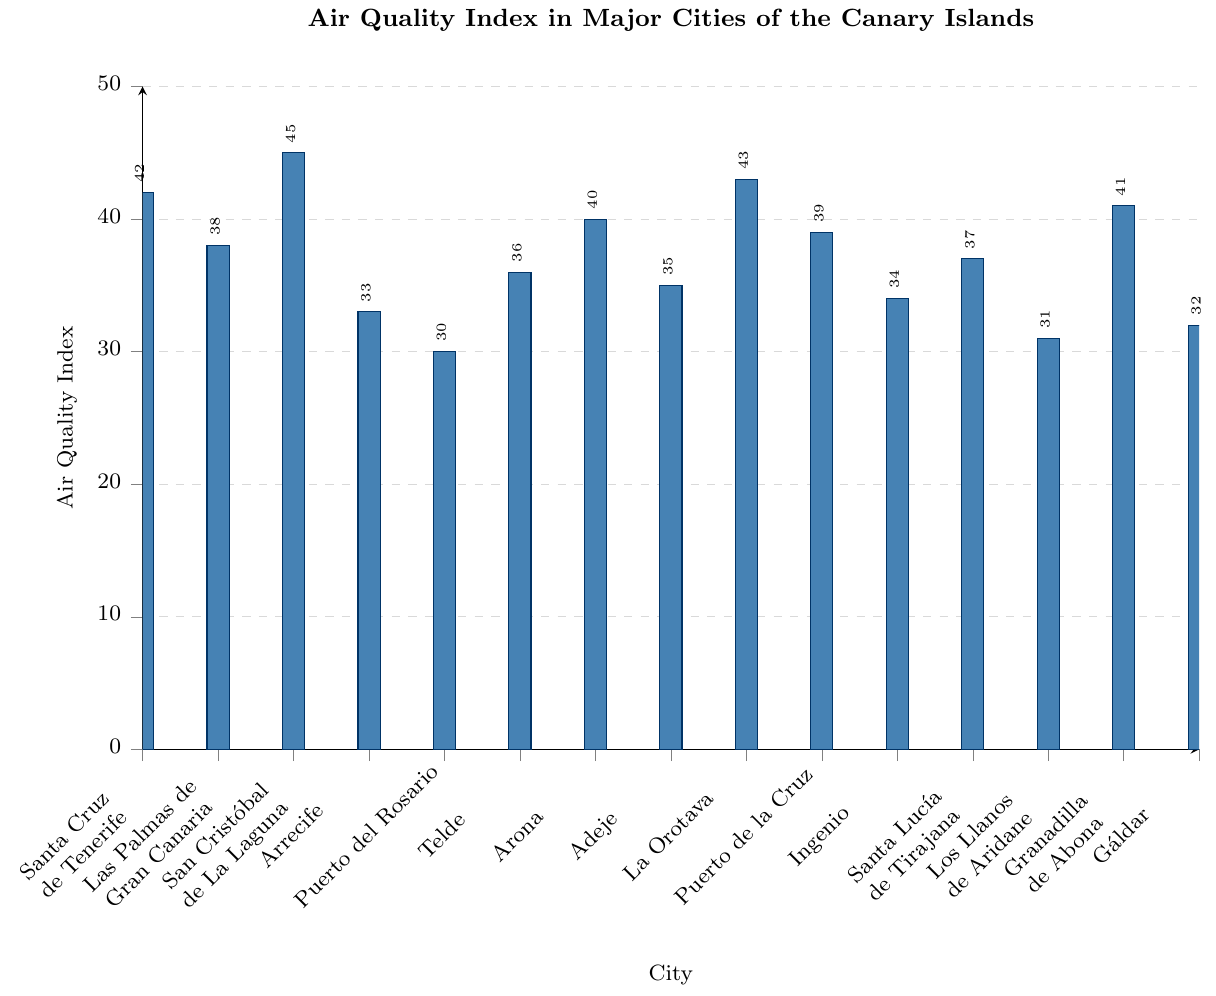which city has the highest Air Quality Index? Look at the bar heights in the bar chart; the city with the tallest bar represents the highest Air Quality Index. San Cristóbal de La Laguna has the highest Air Quality Index with a value of 45.
Answer: San Cristóbal de La Laguna which city has the lowest Air Quality Index? Look at the bar heights in the bar chart; the city with the shortest bar represents the lowest Air Quality Index. Puerto del Rosario has the lowest Air Quality Index with a value of 30.
Answer: Puerto del Rosario what is the average Air Quality Index for all cities? Add up all the Air Quality Index values and divide by the number of cities: (42 + 38 + 45 + 33 + 30 + 36 + 40 + 35 + 43 + 39 + 34 + 37 + 31 + 41 + 32) / 15 = 38.13
Answer: 38.13 is the Air Quality Index of Puerto de la Cruz higher than that of Telde? Compare the bar heights of Puerto de la Cruz and Telde in the chart. Puerto de la Cruz has an Air Quality Index of 39, and Telde has an Air Quality Index of 36. Therefore, Puerto de la Cruz has a higher AQI.
Answer: Yes what is the difference in the Air Quality Index between Granadilla de Abona and Gáldar? Subtract the Air Quality Index of Gáldar from that of Granadilla de Abona: 41 - 32 = 9.
Answer: 9 how many cities have an Air Quality Index above 40? Count the number of bars that exceed the 40 marker on the y-axis. There are 5 cities: Santa Cruz de Tenerife (42), San Cristóbal de La Laguna (45), La Orotava (43), Granadilla de Abona (41), and Arona (40).
Answer: 5 which cities have an Air Quality Index equal to or below 35? Identify the cities corresponding to bars at or below the 35 marker. The cities are Arrecife (33), Puerto del Rosario (30), Adeje (35), Ingenio (34), Los Llanos de Aridane (31), and Gáldar (32).
Answer: Arrecife, Puerto del Rosario, Adeje, Ingenio, Los Llanos de Aridane, Gáldar which three cities have the closest Air Quality Index values? Identify and compare the neighboring bars. Las Palmas de Gran Canaria (38), Santa Lucía de Tirajana (37), and Telde (36) are the closest.
Answer: Las Palmas de Gran Canaria, Santa Lucía de Tirajana, Telde what is the median Air Quality Index value of the cities? Arrange the Air Quality Index values in ascending order: 30, 31, 32, 33, 34, 35, 36, 37, 38, 39, 40, 41, 42, 43, 45. The median value is the middle value of the ordered list, which is 38.
Answer: 38 